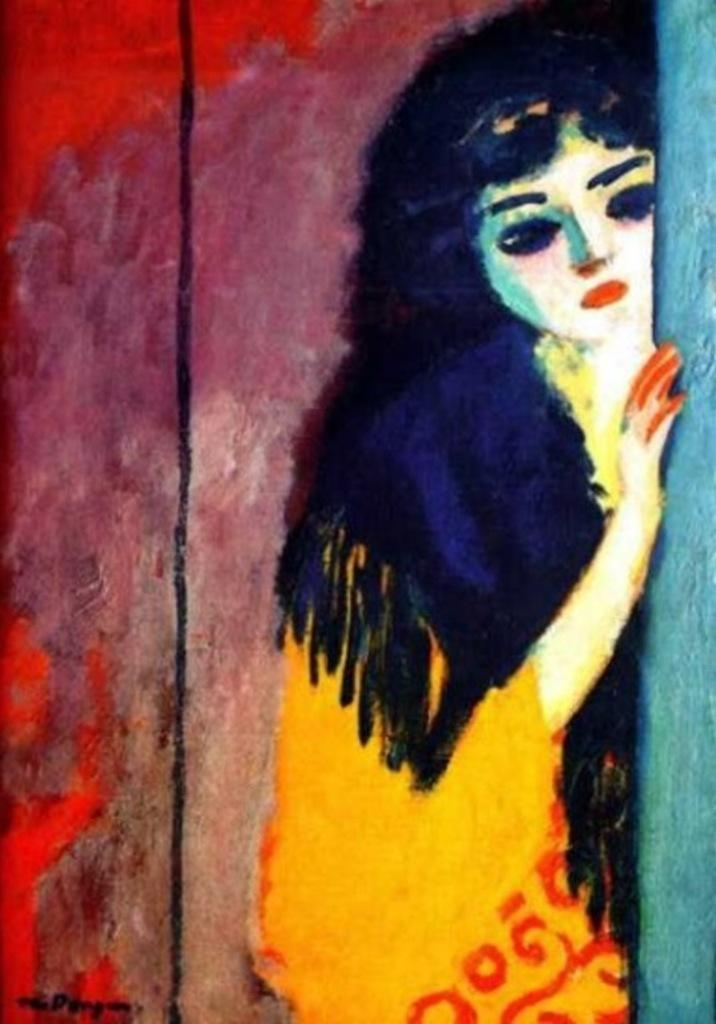What type of artwork is depicted in the image? The image is a painting. What figure can be seen in the painting? There is a woman standing in the painting. What type of yarn is the woman holding in the painting? There is no yarn present in the painting; the woman is not holding any yarn. 